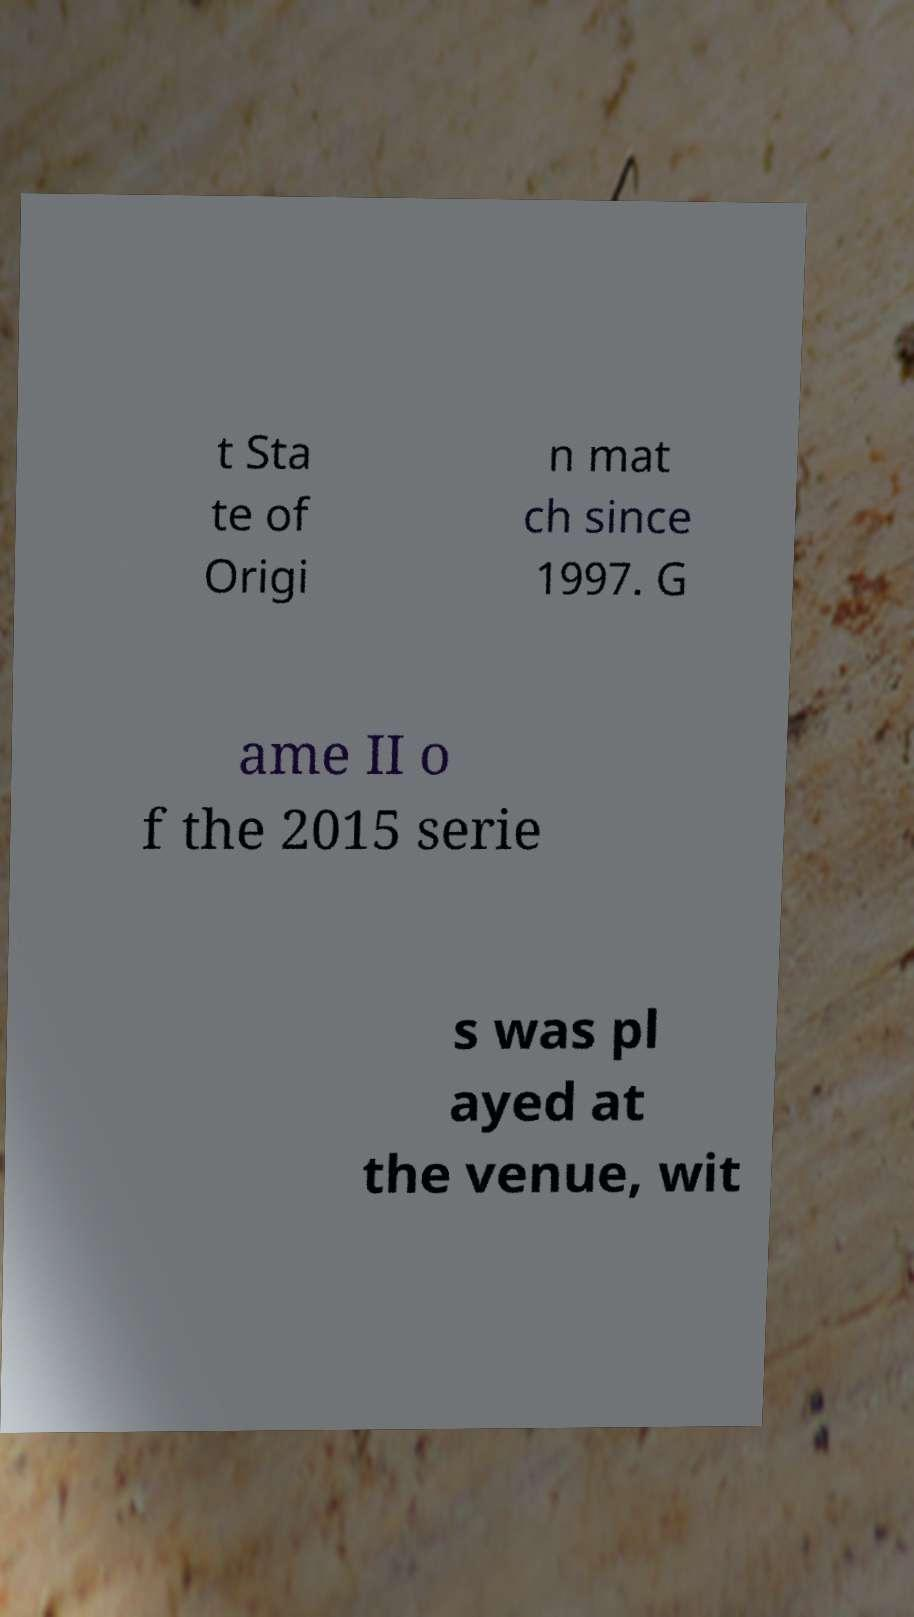Could you extract and type out the text from this image? t Sta te of Origi n mat ch since 1997. G ame II o f the 2015 serie s was pl ayed at the venue, wit 